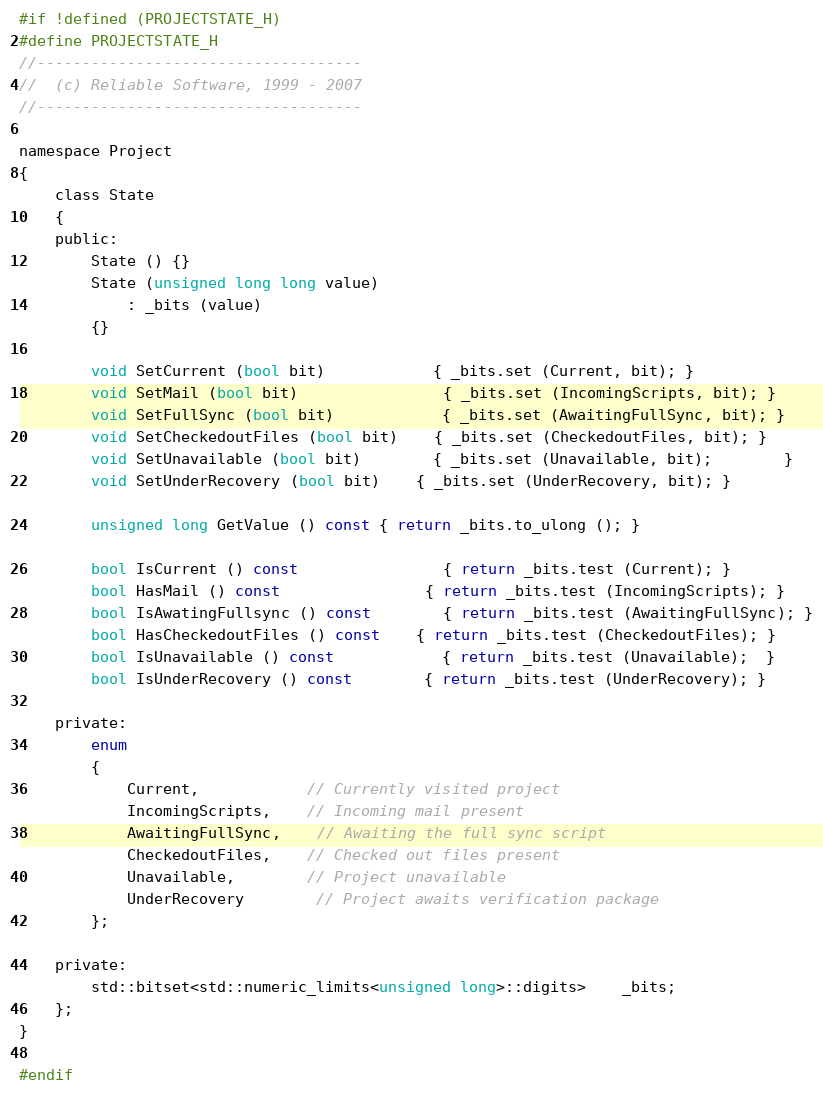<code> <loc_0><loc_0><loc_500><loc_500><_C_>#if !defined (PROJECTSTATE_H)
#define PROJECTSTATE_H
//------------------------------------
//  (c) Reliable Software, 1999 - 2007
//------------------------------------

namespace Project
{
	class State
	{
	public:
		State () {}
		State (unsigned long long value)
			: _bits (value)
		{}

		void SetCurrent (bool bit)			{ _bits.set (Current, bit); }
		void SetMail (bool bit)				{ _bits.set (IncomingScripts, bit); }
		void SetFullSync (bool bit)			{ _bits.set (AwaitingFullSync, bit); }
		void SetCheckedoutFiles (bool bit)	{ _bits.set (CheckedoutFiles, bit); }
		void SetUnavailable (bool bit)		{ _bits.set (Unavailable, bit);		}
		void SetUnderRecovery (bool bit)	{ _bits.set (UnderRecovery, bit); }

		unsigned long GetValue () const { return _bits.to_ulong (); }
	 
		bool IsCurrent () const				{ return _bits.test (Current); }
		bool HasMail () const				{ return _bits.test (IncomingScripts); }
		bool IsAwatingFullsync () const		{ return _bits.test (AwaitingFullSync); }
		bool HasCheckedoutFiles () const	{ return _bits.test (CheckedoutFiles); }
		bool IsUnavailable () const			{ return _bits.test (Unavailable);  }
		bool IsUnderRecovery () const		{ return _bits.test (UnderRecovery); }

	private:
		enum
		{
			Current,			// Currently visited project
			IncomingScripts,	// Incoming mail present
			AwaitingFullSync,	// Awaiting the full sync script
			CheckedoutFiles,	// Checked out files present
			Unavailable,		// Project unavailable
			UnderRecovery		// Project awaits verification package
		};

	private:
		std::bitset<std::numeric_limits<unsigned long>::digits>	_bits;
	};
}

#endif
</code> 